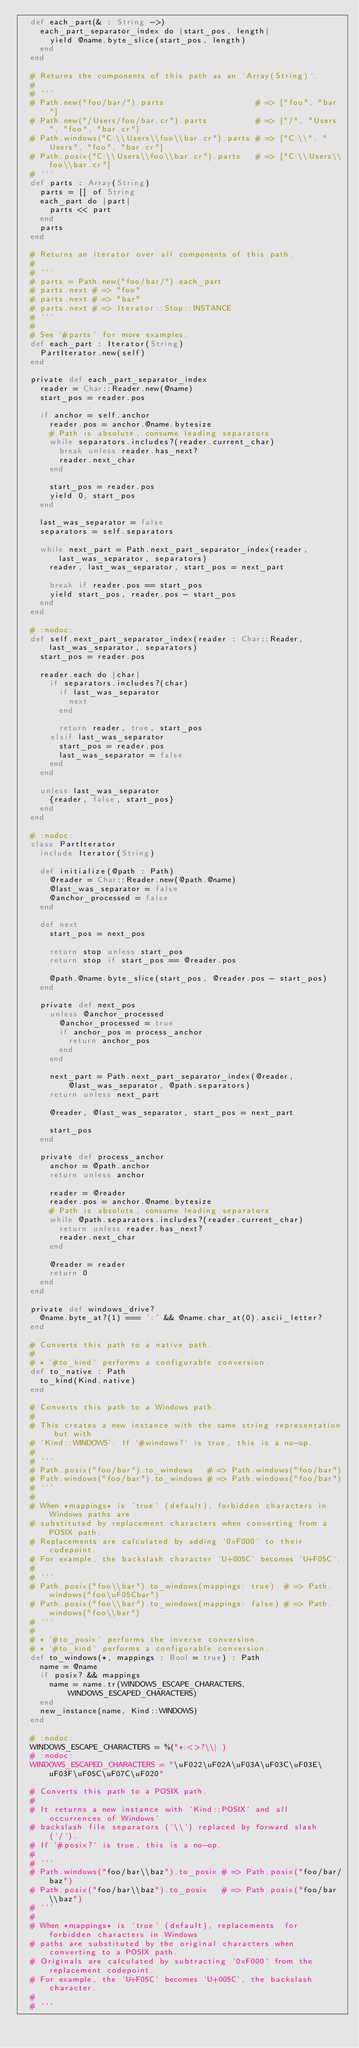<code> <loc_0><loc_0><loc_500><loc_500><_Crystal_>  def each_part(& : String ->)
    each_part_separator_index do |start_pos, length|
      yield @name.byte_slice(start_pos, length)
    end
  end

  # Returns the components of this path as an `Array(String)`.
  #
  # ```
  # Path.new("foo/bar/").parts                   # => ["foo", "bar"]
  # Path.new("/Users/foo/bar.cr").parts          # => ["/", "Users", "foo", "bar.cr"]
  # Path.windows("C:\\Users\\foo\\bar.cr").parts # => ["C:\\", "Users", "foo", "bar.cr"]
  # Path.posix("C:\\Users\\foo\\bar.cr").parts   # => ["C:\\Users\\foo\\bar.cr"]
  # ```
  def parts : Array(String)
    parts = [] of String
    each_part do |part|
      parts << part
    end
    parts
  end

  # Returns an iterator over all components of this path.
  #
  # ```
  # parts = Path.new("foo/bar/").each_part
  # parts.next # => "foo"
  # parts.next # => "bar"
  # parts.next # => Iterator::Stop::INSTANCE
  # ```
  #
  # See `#parts` for more examples.
  def each_part : Iterator(String)
    PartIterator.new(self)
  end

  private def each_part_separator_index
    reader = Char::Reader.new(@name)
    start_pos = reader.pos

    if anchor = self.anchor
      reader.pos = anchor.@name.bytesize
      # Path is absolute, consume leading separators
      while separators.includes?(reader.current_char)
        break unless reader.has_next?
        reader.next_char
      end

      start_pos = reader.pos
      yield 0, start_pos
    end

    last_was_separator = false
    separators = self.separators

    while next_part = Path.next_part_separator_index(reader, last_was_separator, separators)
      reader, last_was_separator, start_pos = next_part

      break if reader.pos == start_pos
      yield start_pos, reader.pos - start_pos
    end
  end

  # :nodoc:
  def self.next_part_separator_index(reader : Char::Reader, last_was_separator, separators)
    start_pos = reader.pos

    reader.each do |char|
      if separators.includes?(char)
        if last_was_separator
          next
        end

        return reader, true, start_pos
      elsif last_was_separator
        start_pos = reader.pos
        last_was_separator = false
      end
    end

    unless last_was_separator
      {reader, false, start_pos}
    end
  end

  # :nodoc:
  class PartIterator
    include Iterator(String)

    def initialize(@path : Path)
      @reader = Char::Reader.new(@path.@name)
      @last_was_separator = false
      @anchor_processed = false
    end

    def next
      start_pos = next_pos

      return stop unless start_pos
      return stop if start_pos == @reader.pos

      @path.@name.byte_slice(start_pos, @reader.pos - start_pos)
    end

    private def next_pos
      unless @anchor_processed
        @anchor_processed = true
        if anchor_pos = process_anchor
          return anchor_pos
        end
      end

      next_part = Path.next_part_separator_index(@reader, @last_was_separator, @path.separators)
      return unless next_part

      @reader, @last_was_separator, start_pos = next_part

      start_pos
    end

    private def process_anchor
      anchor = @path.anchor
      return unless anchor

      reader = @reader
      reader.pos = anchor.@name.bytesize
      # Path is absolute, consume leading separators
      while @path.separators.includes?(reader.current_char)
        return unless reader.has_next?
        reader.next_char
      end

      @reader = reader
      return 0
    end
  end

  private def windows_drive?
    @name.byte_at?(1) === ':' && @name.char_at(0).ascii_letter?
  end

  # Converts this path to a native path.
  #
  # * `#to_kind` performs a configurable conversion.
  def to_native : Path
    to_kind(Kind.native)
  end

  # Converts this path to a Windows path.
  #
  # This creates a new instance with the same string representation but with
  # `Kind::WINDOWS`. If `#windows?` is true, this is a no-op.
  #
  # ```
  # Path.posix("foo/bar").to_windows   # => Path.windows("foo/bar")
  # Path.windows("foo/bar").to_windows # => Path.windows("foo/bar")
  # ```
  #
  # When *mappings* is `true` (default), forbidden characters in Windows paths are
  # substituted by replacement characters when converting from a POSIX path.
  # Replacements are calculated by adding `0xF000` to their codepoint.
  # For example, the backslash character `U+005C` becomes `U+F05C`.
  #
  # ```
  # Path.posix("foo\\bar").to_windows(mappings: true)  # => Path.windows("foo\uF05Cbar")
  # Path.posix("foo\\bar").to_windows(mappings: false) # => Path.windows("foo\\bar")
  # ```
  #
  # * `#to_posix` performs the inverse conversion.
  # * `#to_kind` performs a configurable conversion.
  def to_windows(*, mappings : Bool = true) : Path
    name = @name
    if posix? && mappings
      name = name.tr(WINDOWS_ESCAPE_CHARACTERS, WINDOWS_ESCAPED_CHARACTERS)
    end
    new_instance(name, Kind::WINDOWS)
  end

  # :nodoc:
  WINDOWS_ESCAPE_CHARACTERS = %("*:<>?\\| )
  # :nodoc:
  WINDOWS_ESCAPED_CHARACTERS = "\uF022\uF02A\uF03A\uF03C\uF03E\uF03F\uF05C\uF07C\uF020"

  # Converts this path to a POSIX path.
  #
  # It returns a new instance with `Kind::POSIX` and all occurrences of Windows'
  # backslash file separators (`\\`) replaced by forward slash (`/`).
  # If `#posix?` is true, this is a no-op.
  #
  # ```
  # Path.windows("foo/bar\\baz").to_posix # => Path.posix("foo/bar/baz")
  # Path.posix("foo/bar\\baz").to_posix   # => Path.posix("foo/bar\\baz")
  # ```
  #
  # When *mappings* is `true` (default), replacements  for forbidden characters in Windows
  # paths are substituted by the original characters when converting to a POSIX path.
  # Originals are calculated by subtracting `0xF000` from the replacement codepoint.
  # For example, the `U+F05C` becomes `U+005C`, the backslash character.
  #
  # ```</code> 